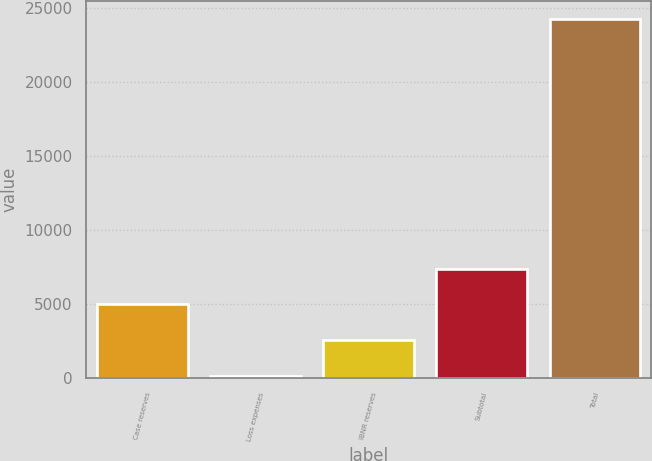<chart> <loc_0><loc_0><loc_500><loc_500><bar_chart><fcel>Case reserves<fcel>Loss expenses<fcel>IBNR reserves<fcel>Subtotal<fcel>Total<nl><fcel>4985.8<fcel>172<fcel>2578.9<fcel>7392.7<fcel>24241<nl></chart> 